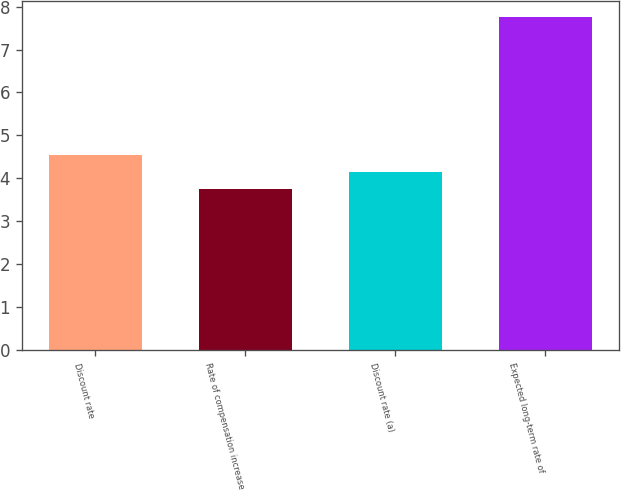<chart> <loc_0><loc_0><loc_500><loc_500><bar_chart><fcel>Discount rate<fcel>Rate of compensation increase<fcel>Discount rate (a)<fcel>Expected long-term rate of<nl><fcel>4.55<fcel>3.75<fcel>4.15<fcel>7.75<nl></chart> 